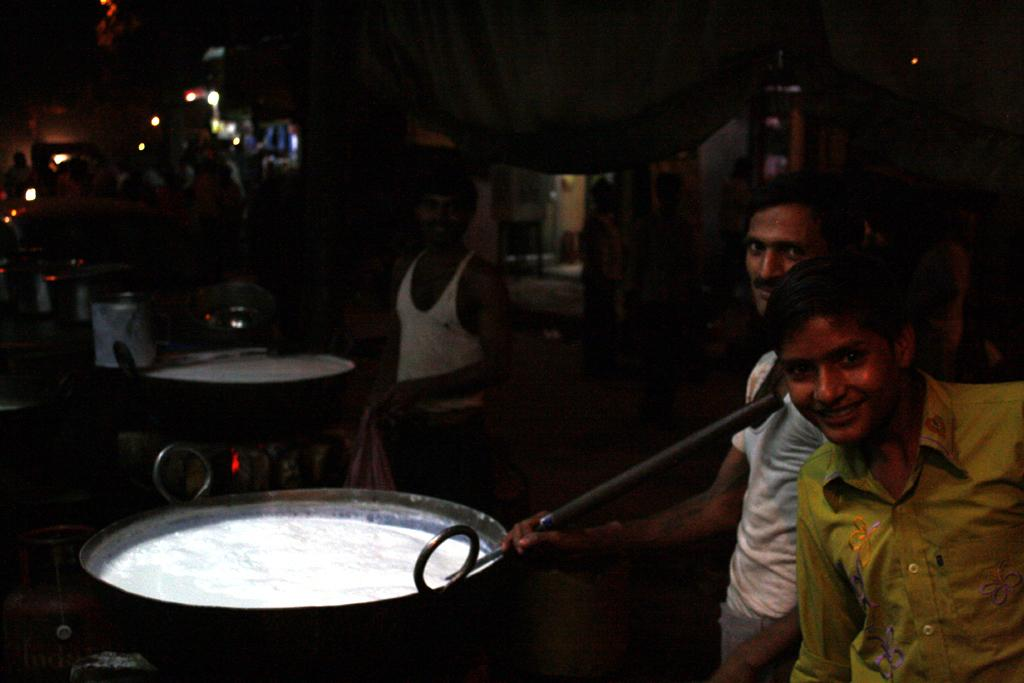Who or what can be seen in the image? There are people in the image. What are the people holding or using in the image? There are bowls in the image, which might be held or used by the people. What can be seen illuminating the scene in the image? There are lights in the image. What other objects can be seen in the image besides the people, bowls, and lights? There are other objects in the image. How would you describe the overall appearance of the background in the image? The background of the image is dark. What type of produce is being punished in the image? There is no produce or punishment present in the image. What is the opinion of the people in the image about a certain topic? The image does not provide any information about the people's opinions on any topic. 